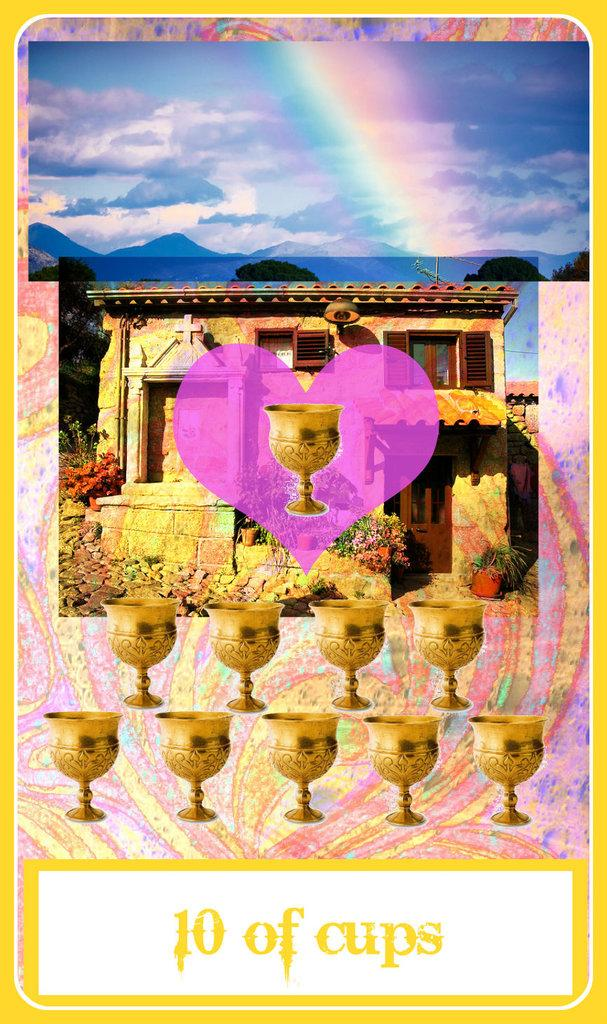<image>
Offer a succinct explanation of the picture presented. Poster showing many cups and the words 10 of Cups on the bottom. 